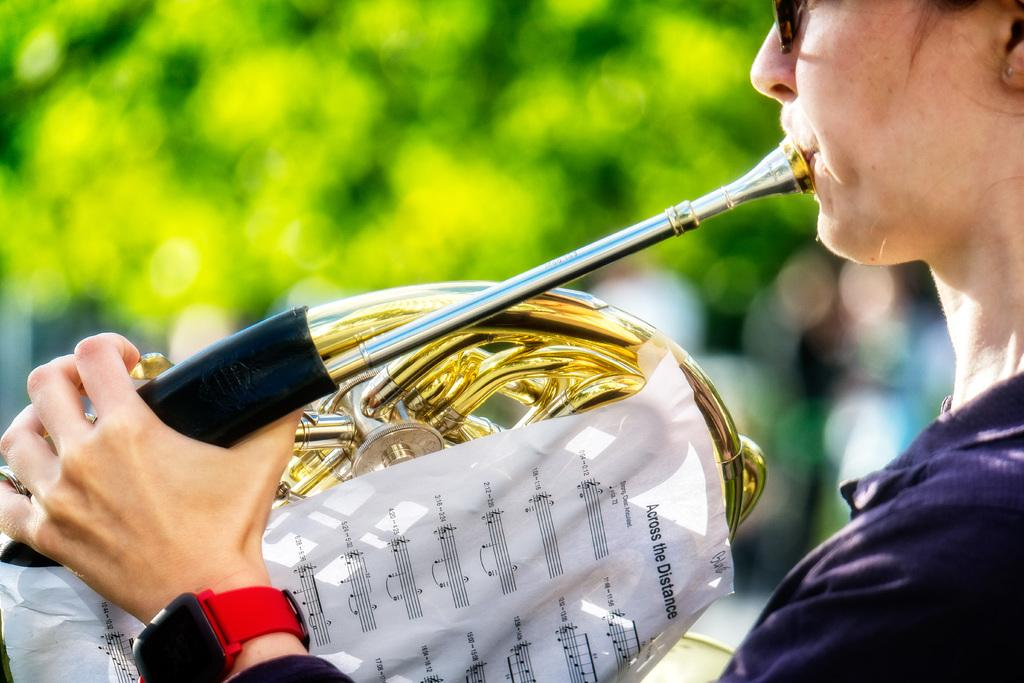<image>
Offer a succinct explanation of the picture presented. A person playing an instrument, the words Across the Distance are visible. 